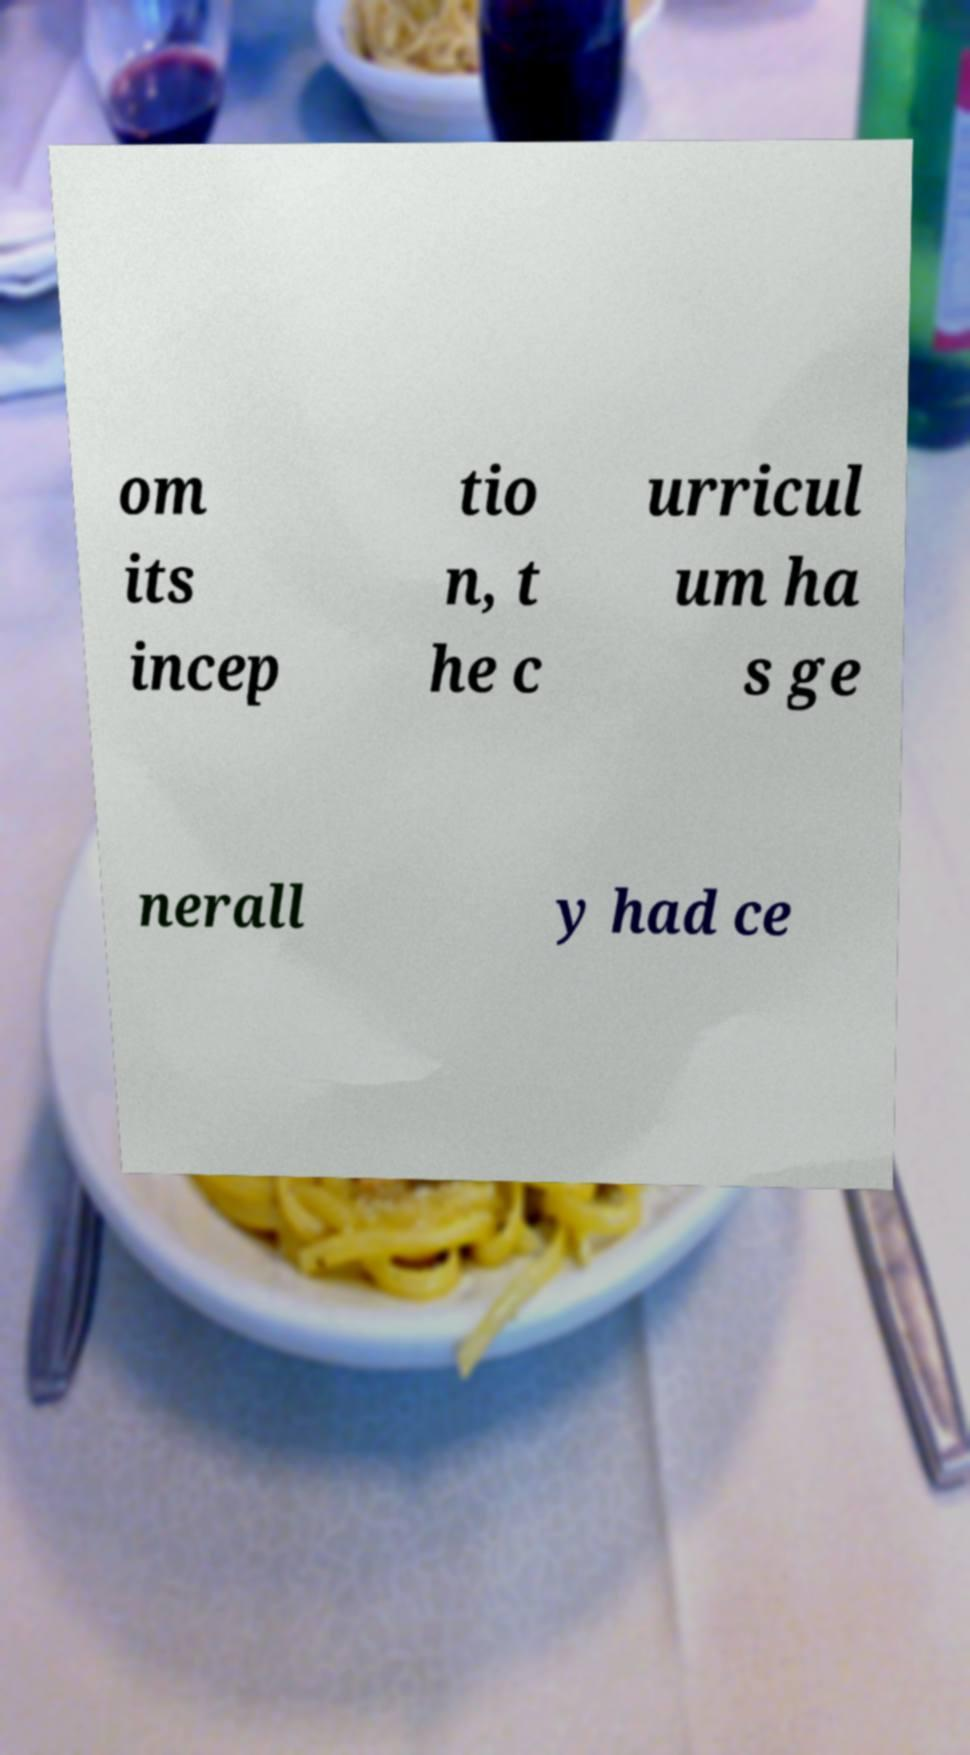Could you extract and type out the text from this image? om its incep tio n, t he c urricul um ha s ge nerall y had ce 